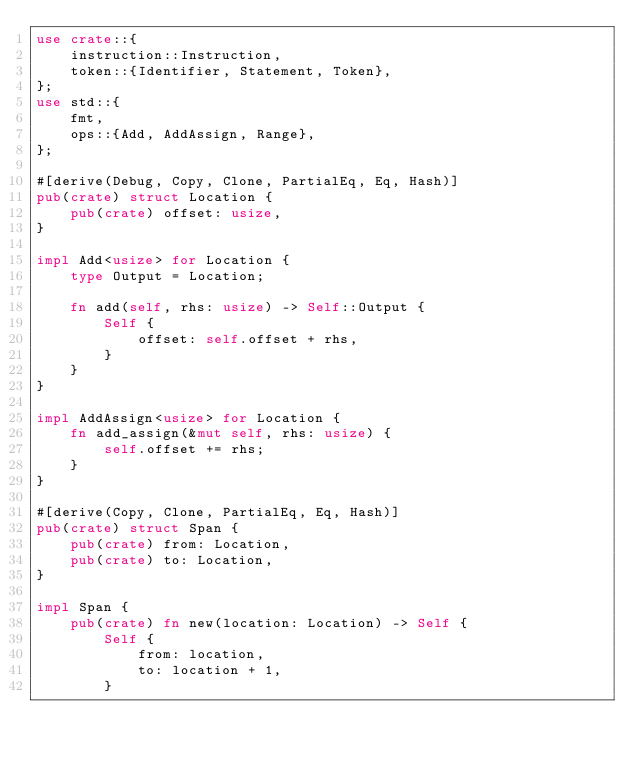<code> <loc_0><loc_0><loc_500><loc_500><_Rust_>use crate::{
    instruction::Instruction,
    token::{Identifier, Statement, Token},
};
use std::{
    fmt,
    ops::{Add, AddAssign, Range},
};

#[derive(Debug, Copy, Clone, PartialEq, Eq, Hash)]
pub(crate) struct Location {
    pub(crate) offset: usize,
}

impl Add<usize> for Location {
    type Output = Location;

    fn add(self, rhs: usize) -> Self::Output {
        Self {
            offset: self.offset + rhs,
        }
    }
}

impl AddAssign<usize> for Location {
    fn add_assign(&mut self, rhs: usize) {
        self.offset += rhs;
    }
}

#[derive(Copy, Clone, PartialEq, Eq, Hash)]
pub(crate) struct Span {
    pub(crate) from: Location,
    pub(crate) to: Location,
}

impl Span {
    pub(crate) fn new(location: Location) -> Self {
        Self {
            from: location,
            to: location + 1,
        }</code> 